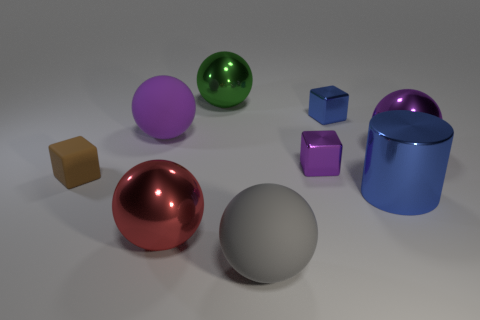The large gray object has what shape?
Offer a terse response. Sphere. There is a large purple thing that is on the left side of the cylinder right of the big shiny sphere to the left of the large green metallic object; what is it made of?
Provide a short and direct response. Rubber. How many other things are made of the same material as the small blue thing?
Your response must be concise. 5. Is the red thing the same size as the brown rubber object?
Ensure brevity in your answer.  No. Are the tiny cube that is left of the big red ball and the purple sphere left of the large blue metallic thing made of the same material?
Ensure brevity in your answer.  Yes. There is a rubber object in front of the cube left of the large gray sphere that is left of the tiny purple shiny cube; what is its shape?
Give a very brief answer. Sphere. Is the number of small brown objects greater than the number of tiny metal cubes?
Provide a short and direct response. No. Are any large green cylinders visible?
Ensure brevity in your answer.  No. What number of things are either large purple balls behind the big purple shiny object or big rubber objects behind the small brown matte cube?
Your answer should be very brief. 1. Is the number of red metallic cylinders less than the number of tiny shiny cubes?
Keep it short and to the point. Yes. 